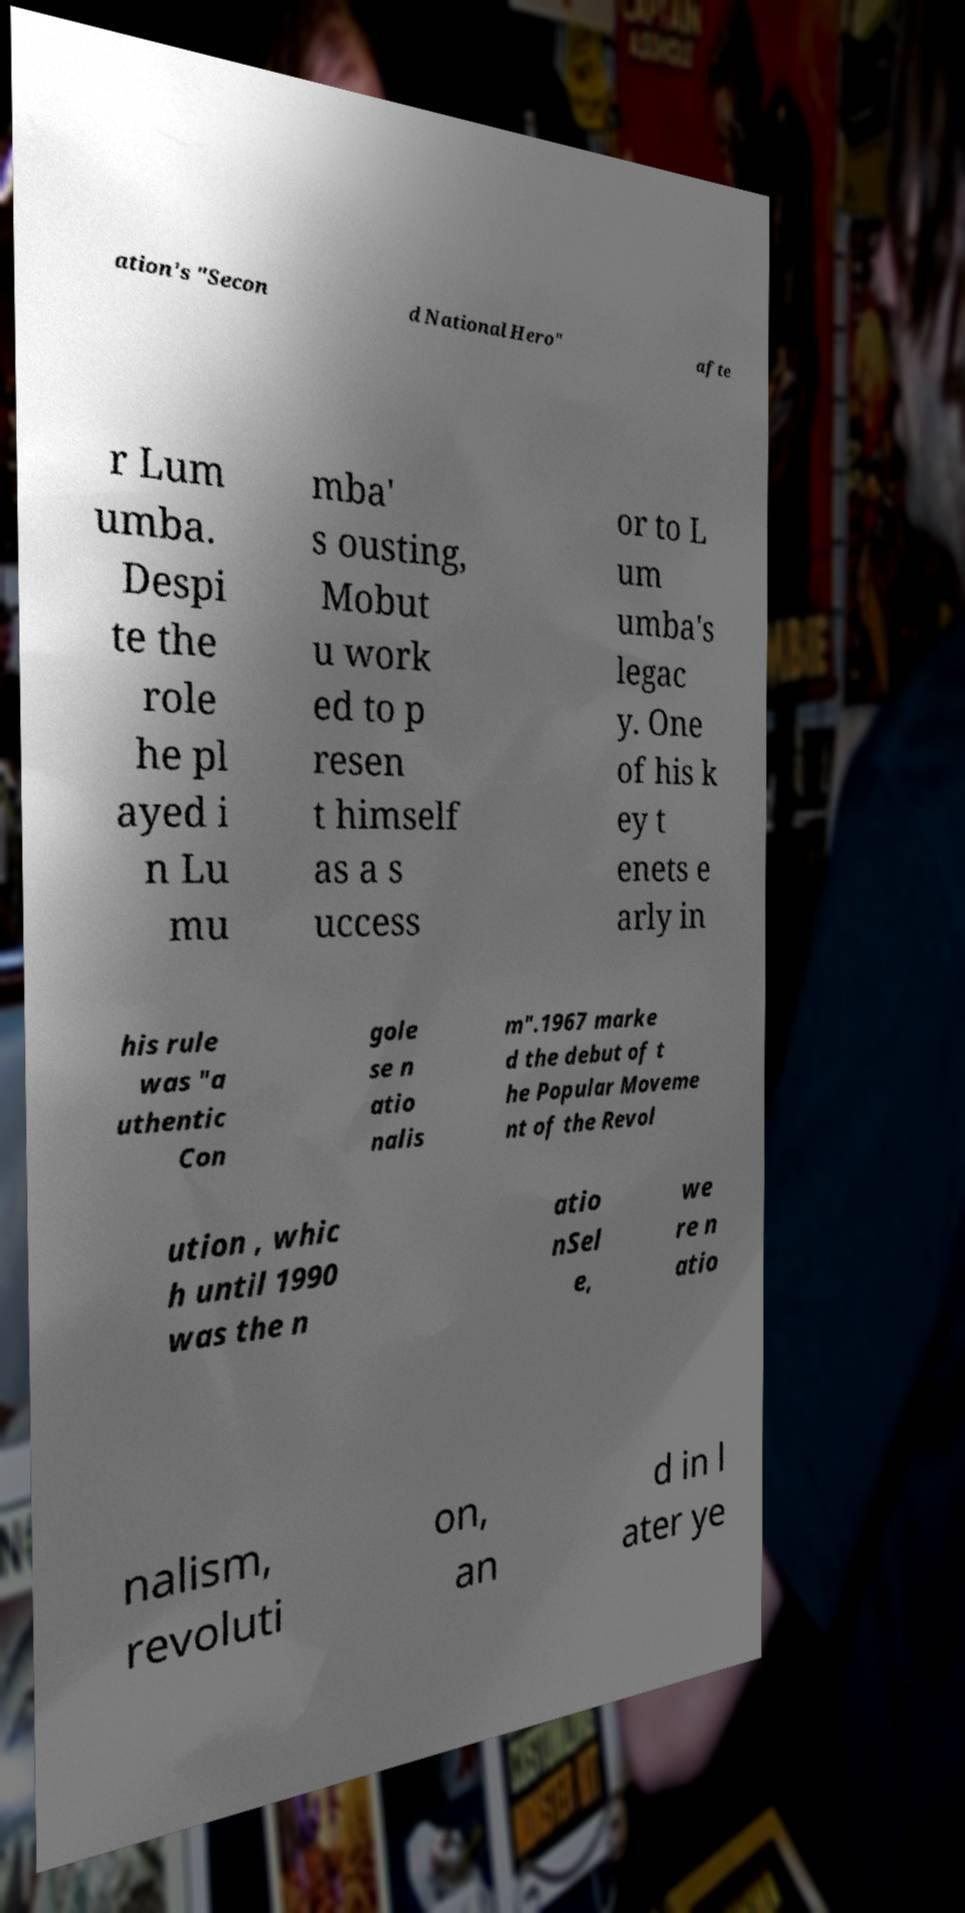Can you accurately transcribe the text from the provided image for me? ation's "Secon d National Hero" afte r Lum umba. Despi te the role he pl ayed i n Lu mu mba' s ousting, Mobut u work ed to p resen t himself as a s uccess or to L um umba's legac y. One of his k ey t enets e arly in his rule was "a uthentic Con gole se n atio nalis m".1967 marke d the debut of t he Popular Moveme nt of the Revol ution , whic h until 1990 was the n atio nSel e, we re n atio nalism, revoluti on, an d in l ater ye 